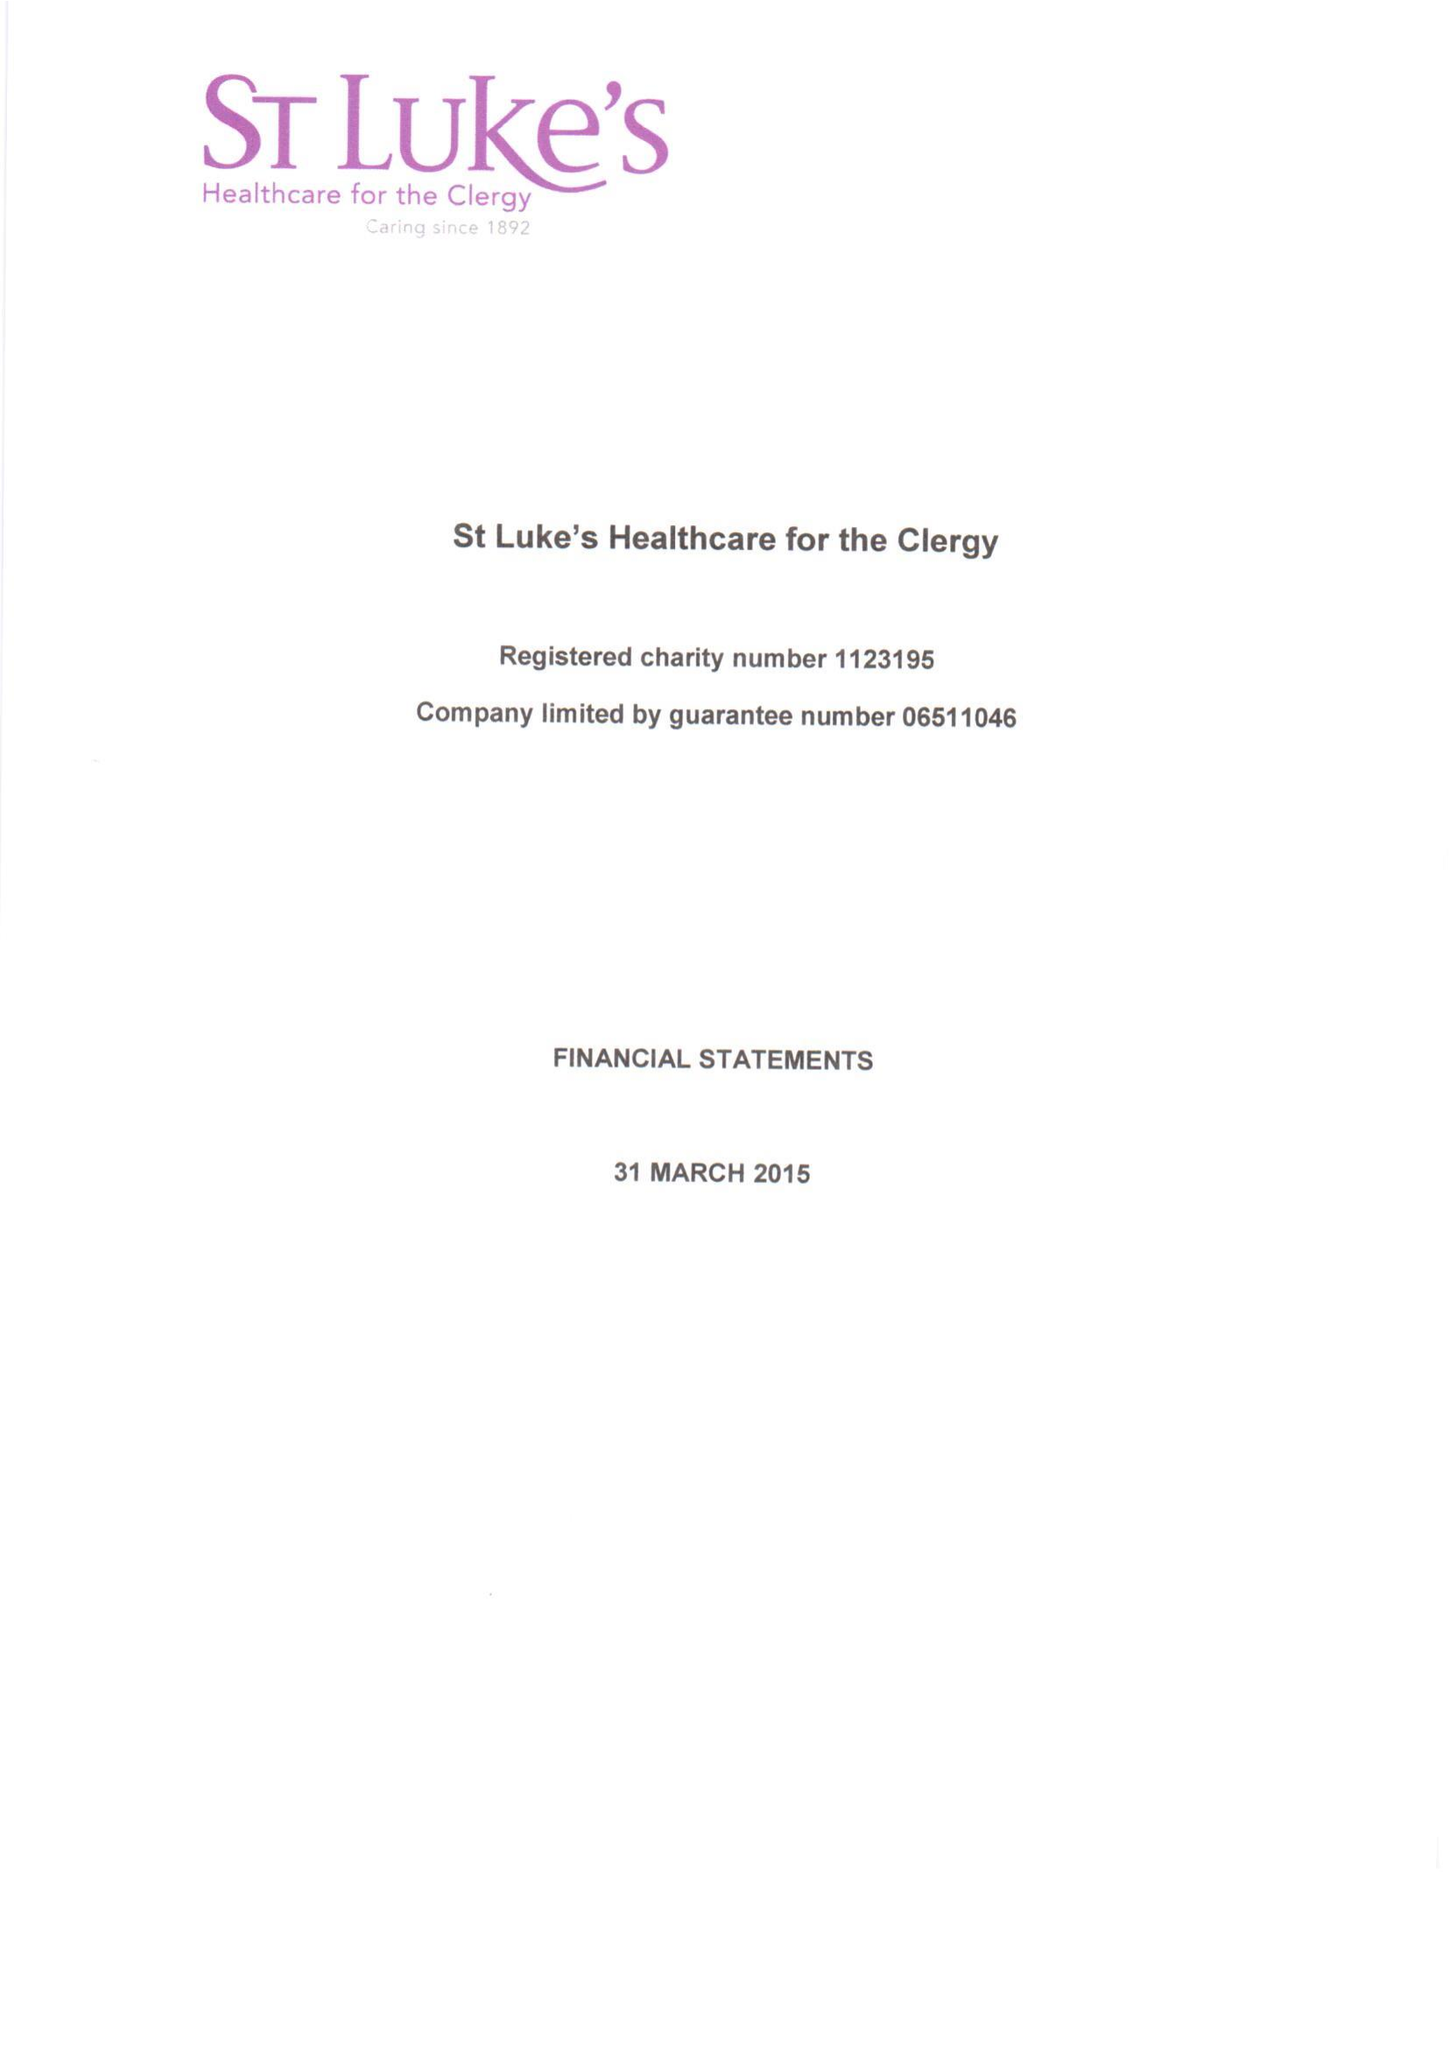What is the value for the report_date?
Answer the question using a single word or phrase. 2015-03-31 